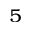Convert formula to latex. <formula><loc_0><loc_0><loc_500><loc_500>^ { 5 }</formula> 